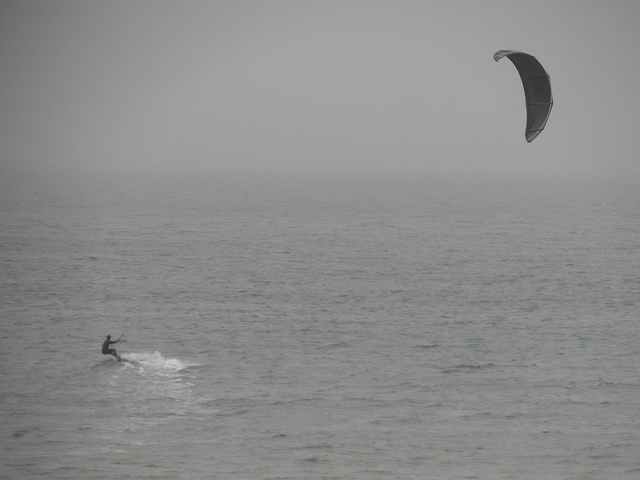Describe the objects in this image and their specific colors. I can see kite in gray, black, and darkgray tones, people in gray and black tones, and surfboard in gray and darkgray tones in this image. 